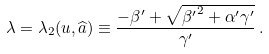Convert formula to latex. <formula><loc_0><loc_0><loc_500><loc_500>\lambda = \lambda _ { 2 } ( u , \widehat { a } ) \equiv \frac { - \beta ^ { \prime } + \sqrt { { \beta ^ { \prime } } ^ { 2 } + \alpha ^ { \prime } \gamma ^ { \prime } } } { \gamma ^ { \prime } } \, .</formula> 